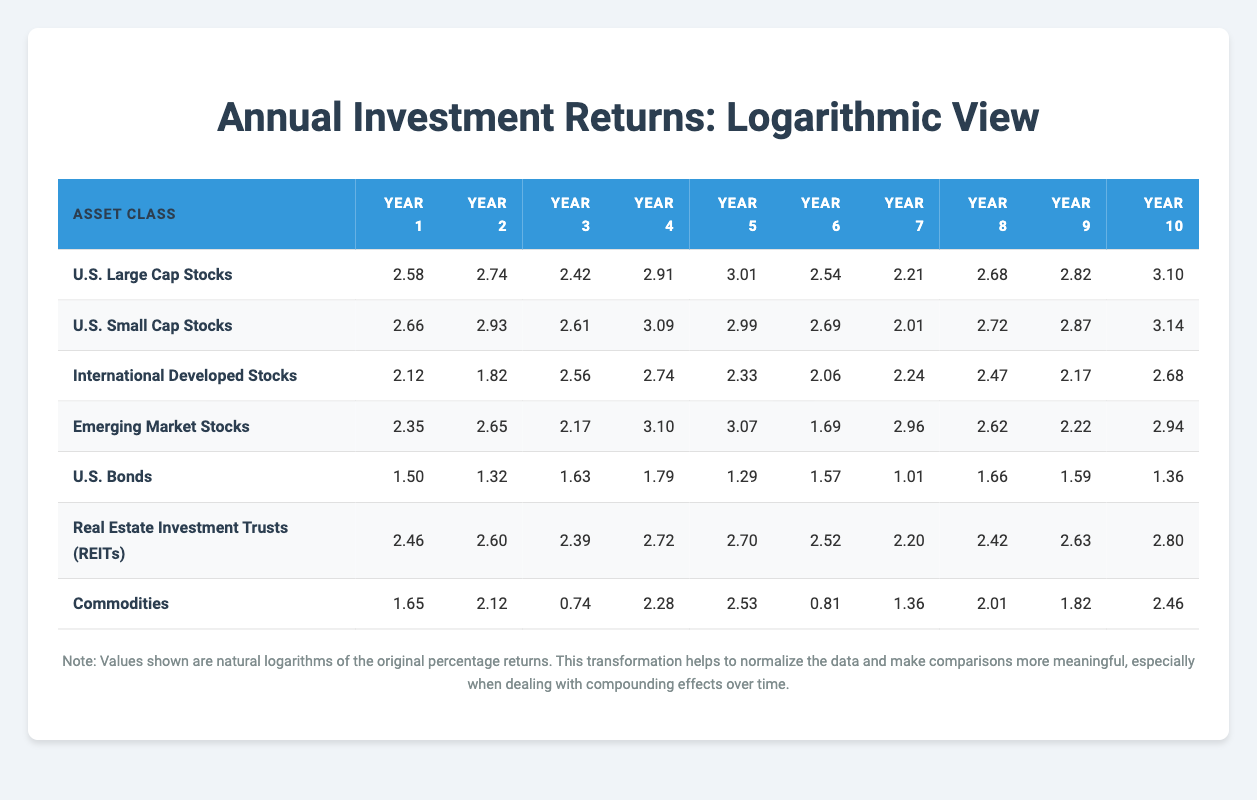What was the highest return recorded for U.S. Large Cap Stocks? The highest value for U.S. Large Cap Stocks is in Year 10 where the return is 22.10. Therefore, this is the highest recorded return for this asset class.
Answer: 22.10 What is the average return for U.S. Bonds over the decade? To find the average for U.S. Bonds, sum all the returns: (4.50 + 3.75 + 5.10 + 6.00 + 3.65 + 4.80 + 2.75 + 5.25 + 4.90 + 3.90) = 44.70. There are 10 years, so the average is 44.70 / 10 = 4.47.
Answer: 4.47 Which asset class had the highest return in Year 5? By comparing Year 5 returns across all asset classes, U.S. Large Cap Stocks had a return of 20.25, which is higher than all others listed for that year.
Answer: U.S. Large Cap Stocks Did International Developed Stocks have a higher return than U.S. Bonds in Year 3? In Year 3, International Developed Stocks had a return of 12.90 while U.S. Bonds had a return of 5.10. Since 12.90 > 5.10, it is true that International Developed Stocks had a higher return.
Answer: Yes What is the difference in return between U.S. Small Cap Stocks and Emerging Market Stocks in Year 8? In Year 8, U.S. Small Cap Stocks returned 17.60 and Emerging Market Stocks returned 9.20. The difference is 17.60 - 9.20 = 8.40.
Answer: 8.40 Which asset class showed the most consistent returns over the decade? To check for consistency, observe the variation in values. U.S. Bonds show the smallest range of returns (from 2.75 to 6.00), indicating more consistent performance compared to the other asset classes with wider ranges.
Answer: U.S. Bonds What was the sum of the returns for Real Estate Investment Trusts (REITs) from Year 1 to Year 10? Summing the values: (11.70 + 13.40 + 10.95 + 15.15 + 14.88 + 12.45 + 9.00 + 11.20 + 13.85 + 16.50) = 127.08.
Answer: 127.08 In which year did Commodities record a negative return? Commodities recorded a negative return in Year 3, where the return is -2.10.
Answer: Year 3 How do the average returns of Small Cap Stocks and Emerging Market Stocks compare over the decade? Calculate the averages: Small Cap Stocks average is 17.29 (summing and dividing) and Emerging Market Stocks average is 14.51. Since 17.29 > 14.51, Small Cap Stocks had a higher average return.
Answer: Small Cap Stocks had a higher average return What was the minimum return recorded for Commodities during the decade? The minimum return for Commodities, looking through the values from Year 1 to Year 10, is -2.10 in Year 3. Thus, -2.10 is the lowest point for this asset class.
Answer: -2.10 